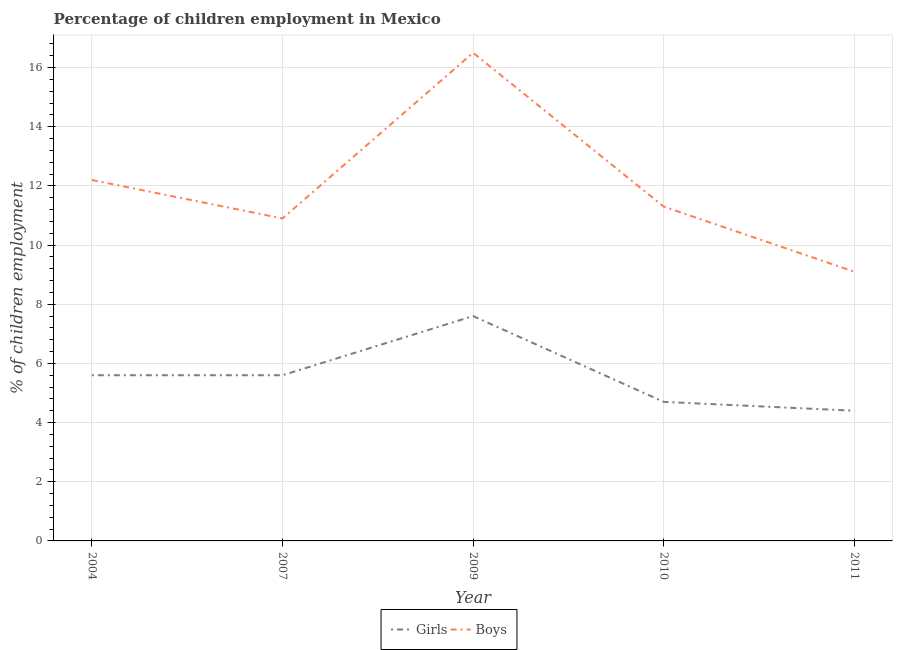How many different coloured lines are there?
Offer a very short reply. 2. Does the line corresponding to percentage of employed girls intersect with the line corresponding to percentage of employed boys?
Keep it short and to the point. No. Across all years, what is the minimum percentage of employed girls?
Offer a very short reply. 4.4. In which year was the percentage of employed girls minimum?
Provide a short and direct response. 2011. What is the total percentage of employed boys in the graph?
Make the answer very short. 60. What is the difference between the percentage of employed girls in 2010 and that in 2011?
Give a very brief answer. 0.3. What is the difference between the percentage of employed boys in 2011 and the percentage of employed girls in 2009?
Ensure brevity in your answer.  1.5. What is the average percentage of employed girls per year?
Provide a short and direct response. 5.58. In the year 2010, what is the difference between the percentage of employed girls and percentage of employed boys?
Your answer should be very brief. -6.6. What is the ratio of the percentage of employed girls in 2007 to that in 2009?
Ensure brevity in your answer.  0.74. Is the percentage of employed boys in 2007 less than that in 2009?
Make the answer very short. Yes. Is the difference between the percentage of employed girls in 2010 and 2011 greater than the difference between the percentage of employed boys in 2010 and 2011?
Make the answer very short. No. What is the difference between the highest and the second highest percentage of employed boys?
Provide a short and direct response. 4.3. What is the difference between the highest and the lowest percentage of employed girls?
Your answer should be compact. 3.2. In how many years, is the percentage of employed girls greater than the average percentage of employed girls taken over all years?
Your response must be concise. 3. Is the sum of the percentage of employed girls in 2007 and 2010 greater than the maximum percentage of employed boys across all years?
Provide a short and direct response. No. Does the percentage of employed girls monotonically increase over the years?
Provide a succinct answer. No. Is the percentage of employed boys strictly greater than the percentage of employed girls over the years?
Your answer should be very brief. Yes. How many lines are there?
Ensure brevity in your answer.  2. What is the difference between two consecutive major ticks on the Y-axis?
Make the answer very short. 2. Are the values on the major ticks of Y-axis written in scientific E-notation?
Provide a succinct answer. No. Does the graph contain any zero values?
Your response must be concise. No. Where does the legend appear in the graph?
Give a very brief answer. Bottom center. How are the legend labels stacked?
Offer a very short reply. Horizontal. What is the title of the graph?
Ensure brevity in your answer.  Percentage of children employment in Mexico. Does "Taxes on exports" appear as one of the legend labels in the graph?
Offer a terse response. No. What is the label or title of the X-axis?
Make the answer very short. Year. What is the label or title of the Y-axis?
Offer a terse response. % of children employment. What is the % of children employment of Boys in 2004?
Your answer should be compact. 12.2. What is the % of children employment in Girls in 2007?
Your answer should be very brief. 5.6. What is the % of children employment of Boys in 2007?
Give a very brief answer. 10.9. What is the % of children employment of Boys in 2009?
Make the answer very short. 16.5. Across all years, what is the maximum % of children employment of Girls?
Keep it short and to the point. 7.6. Across all years, what is the maximum % of children employment of Boys?
Your response must be concise. 16.5. Across all years, what is the minimum % of children employment in Boys?
Offer a terse response. 9.1. What is the total % of children employment of Girls in the graph?
Your answer should be compact. 27.9. What is the difference between the % of children employment in Girls in 2004 and that in 2007?
Offer a terse response. 0. What is the difference between the % of children employment in Boys in 2004 and that in 2007?
Provide a short and direct response. 1.3. What is the difference between the % of children employment of Boys in 2004 and that in 2009?
Your answer should be compact. -4.3. What is the difference between the % of children employment in Boys in 2004 and that in 2010?
Ensure brevity in your answer.  0.9. What is the difference between the % of children employment of Girls in 2004 and that in 2011?
Keep it short and to the point. 1.2. What is the difference between the % of children employment in Boys in 2004 and that in 2011?
Give a very brief answer. 3.1. What is the difference between the % of children employment in Boys in 2007 and that in 2009?
Provide a short and direct response. -5.6. What is the difference between the % of children employment of Girls in 2007 and that in 2010?
Ensure brevity in your answer.  0.9. What is the difference between the % of children employment of Boys in 2007 and that in 2011?
Make the answer very short. 1.8. What is the difference between the % of children employment in Girls in 2009 and that in 2010?
Make the answer very short. 2.9. What is the difference between the % of children employment of Boys in 2009 and that in 2010?
Keep it short and to the point. 5.2. What is the difference between the % of children employment in Boys in 2010 and that in 2011?
Make the answer very short. 2.2. What is the difference between the % of children employment in Girls in 2004 and the % of children employment in Boys in 2010?
Offer a terse response. -5.7. What is the difference between the % of children employment of Girls in 2004 and the % of children employment of Boys in 2011?
Your response must be concise. -3.5. What is the difference between the % of children employment in Girls in 2007 and the % of children employment in Boys in 2009?
Provide a succinct answer. -10.9. What is the difference between the % of children employment in Girls in 2010 and the % of children employment in Boys in 2011?
Your answer should be compact. -4.4. What is the average % of children employment of Girls per year?
Your answer should be compact. 5.58. What is the average % of children employment in Boys per year?
Give a very brief answer. 12. In the year 2004, what is the difference between the % of children employment in Girls and % of children employment in Boys?
Provide a succinct answer. -6.6. In the year 2010, what is the difference between the % of children employment of Girls and % of children employment of Boys?
Offer a terse response. -6.6. In the year 2011, what is the difference between the % of children employment in Girls and % of children employment in Boys?
Provide a succinct answer. -4.7. What is the ratio of the % of children employment of Girls in 2004 to that in 2007?
Your answer should be compact. 1. What is the ratio of the % of children employment in Boys in 2004 to that in 2007?
Offer a terse response. 1.12. What is the ratio of the % of children employment of Girls in 2004 to that in 2009?
Make the answer very short. 0.74. What is the ratio of the % of children employment of Boys in 2004 to that in 2009?
Offer a terse response. 0.74. What is the ratio of the % of children employment in Girls in 2004 to that in 2010?
Provide a short and direct response. 1.19. What is the ratio of the % of children employment in Boys in 2004 to that in 2010?
Your answer should be very brief. 1.08. What is the ratio of the % of children employment in Girls in 2004 to that in 2011?
Provide a succinct answer. 1.27. What is the ratio of the % of children employment of Boys in 2004 to that in 2011?
Offer a terse response. 1.34. What is the ratio of the % of children employment in Girls in 2007 to that in 2009?
Your answer should be compact. 0.74. What is the ratio of the % of children employment of Boys in 2007 to that in 2009?
Provide a short and direct response. 0.66. What is the ratio of the % of children employment in Girls in 2007 to that in 2010?
Provide a succinct answer. 1.19. What is the ratio of the % of children employment in Boys in 2007 to that in 2010?
Provide a succinct answer. 0.96. What is the ratio of the % of children employment of Girls in 2007 to that in 2011?
Ensure brevity in your answer.  1.27. What is the ratio of the % of children employment of Boys in 2007 to that in 2011?
Give a very brief answer. 1.2. What is the ratio of the % of children employment in Girls in 2009 to that in 2010?
Provide a succinct answer. 1.62. What is the ratio of the % of children employment of Boys in 2009 to that in 2010?
Ensure brevity in your answer.  1.46. What is the ratio of the % of children employment of Girls in 2009 to that in 2011?
Provide a succinct answer. 1.73. What is the ratio of the % of children employment in Boys in 2009 to that in 2011?
Make the answer very short. 1.81. What is the ratio of the % of children employment of Girls in 2010 to that in 2011?
Offer a terse response. 1.07. What is the ratio of the % of children employment in Boys in 2010 to that in 2011?
Ensure brevity in your answer.  1.24. What is the difference between the highest and the second highest % of children employment of Girls?
Provide a succinct answer. 2. What is the difference between the highest and the lowest % of children employment of Girls?
Give a very brief answer. 3.2. 